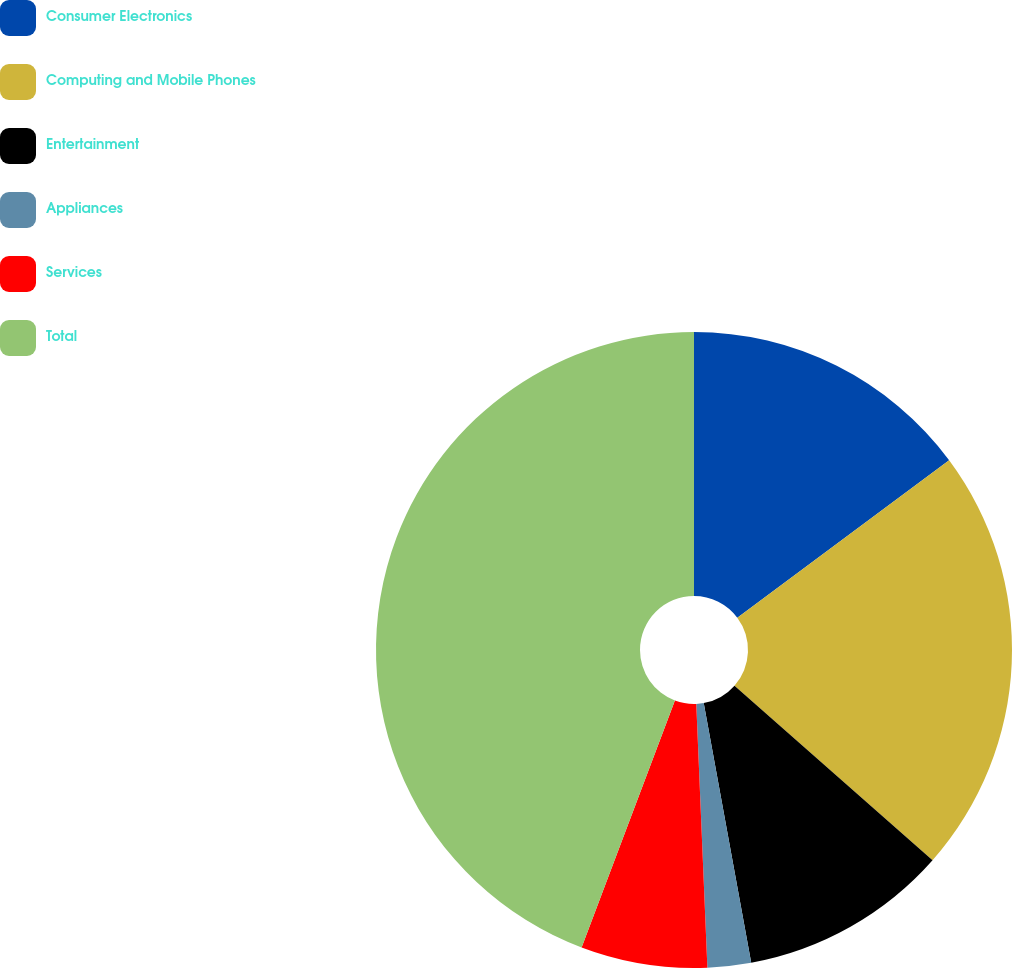<chart> <loc_0><loc_0><loc_500><loc_500><pie_chart><fcel>Consumer Electronics<fcel>Computing and Mobile Phones<fcel>Entertainment<fcel>Appliances<fcel>Services<fcel>Total<nl><fcel>14.82%<fcel>21.68%<fcel>10.62%<fcel>2.21%<fcel>6.42%<fcel>44.25%<nl></chart> 